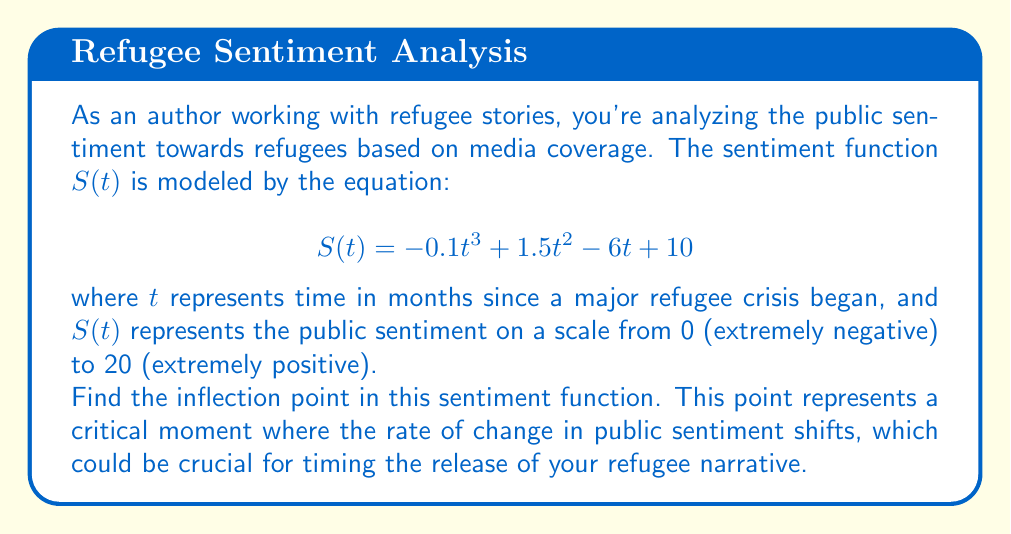Can you answer this question? To find the inflection point, we need to follow these steps:

1) The inflection point occurs where the second derivative of the function equals zero. So, we need to find $S''(t)$ and set it to zero.

2) First, let's find the first derivative $S'(t)$:
   $$S'(t) = -0.3t^2 + 3t - 6$$

3) Now, let's find the second derivative $S''(t)$:
   $$S''(t) = -0.6t + 3$$

4) Set $S''(t) = 0$ and solve for $t$:
   $$-0.6t + 3 = 0$$
   $$-0.6t = -3$$
   $$t = 5$$

5) This gives us the $t$-coordinate of the inflection point. To find the $S$-coordinate, we plug $t=5$ into our original function:

   $$S(5) = -0.1(5^3) + 1.5(5^2) - 6(5) + 10$$
   $$= -12.5 + 37.5 - 30 + 10$$
   $$= 5$$

6) Therefore, the inflection point is at (5, 5).

This point represents the moment, 5 months after the crisis began, when the public sentiment was at 5 on our scale, and the rate of change in sentiment shifted from increasing to decreasing, or vice versa.
Answer: (5, 5) 